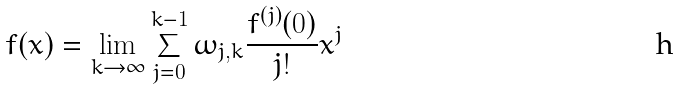Convert formula to latex. <formula><loc_0><loc_0><loc_500><loc_500>f ( x ) = \lim _ { k \to \infty } \sum _ { j = 0 } ^ { k - 1 } \omega _ { j , k } \frac { f ^ { ( j ) } ( 0 ) } { j ! } x ^ { j }</formula> 